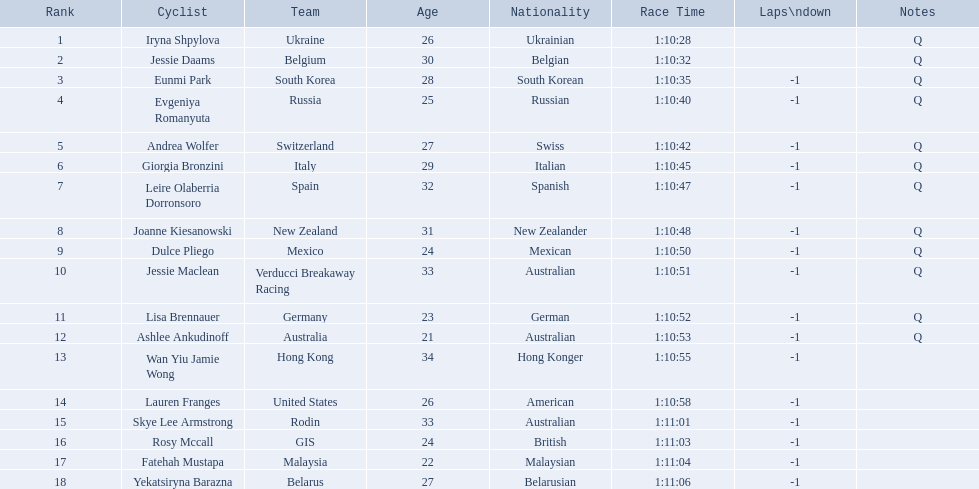Who are all the cyclists? Iryna Shpylova, Jessie Daams, Eunmi Park, Evgeniya Romanyuta, Andrea Wolfer, Giorgia Bronzini, Leire Olaberria Dorronsoro, Joanne Kiesanowski, Dulce Pliego, Jessie Maclean, Lisa Brennauer, Ashlee Ankudinoff, Wan Yiu Jamie Wong, Lauren Franges, Skye Lee Armstrong, Rosy Mccall, Fatehah Mustapa, Yekatsiryna Barazna. What were their ranks? 1, 2, 3, 4, 5, 6, 7, 8, 9, 10, 11, 12, 13, 14, 15, 16, 17, 18. Who was ranked highest? Iryna Shpylova. 